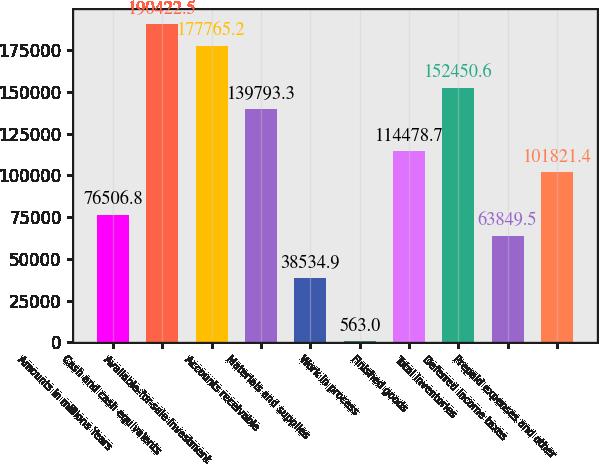Convert chart to OTSL. <chart><loc_0><loc_0><loc_500><loc_500><bar_chart><fcel>Amounts in millions Years<fcel>Cash and cash equivalents<fcel>Available-for-sale investment<fcel>Accounts receivable<fcel>Materials and supplies<fcel>Work in process<fcel>Finished goods<fcel>Total inventories<fcel>Deferred income taxes<fcel>Prepaid expenses and other<nl><fcel>76506.8<fcel>190422<fcel>177765<fcel>139793<fcel>38534.9<fcel>563<fcel>114479<fcel>152451<fcel>63849.5<fcel>101821<nl></chart> 